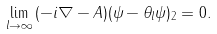Convert formula to latex. <formula><loc_0><loc_0><loc_500><loc_500>\lim _ { l \to \infty } \| ( - i \nabla - A ) ( \psi - \theta _ { l } \psi ) \| _ { 2 } = 0 .</formula> 